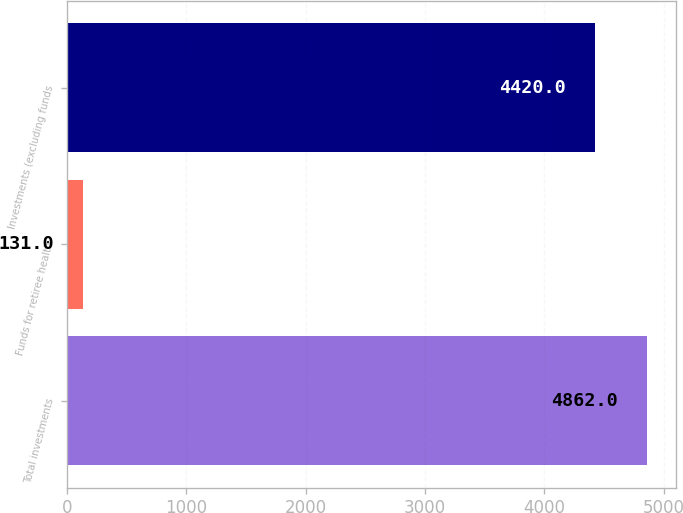Convert chart. <chart><loc_0><loc_0><loc_500><loc_500><bar_chart><fcel>Total investments<fcel>Funds for retiree health<fcel>Investments (excluding funds<nl><fcel>4862<fcel>131<fcel>4420<nl></chart> 